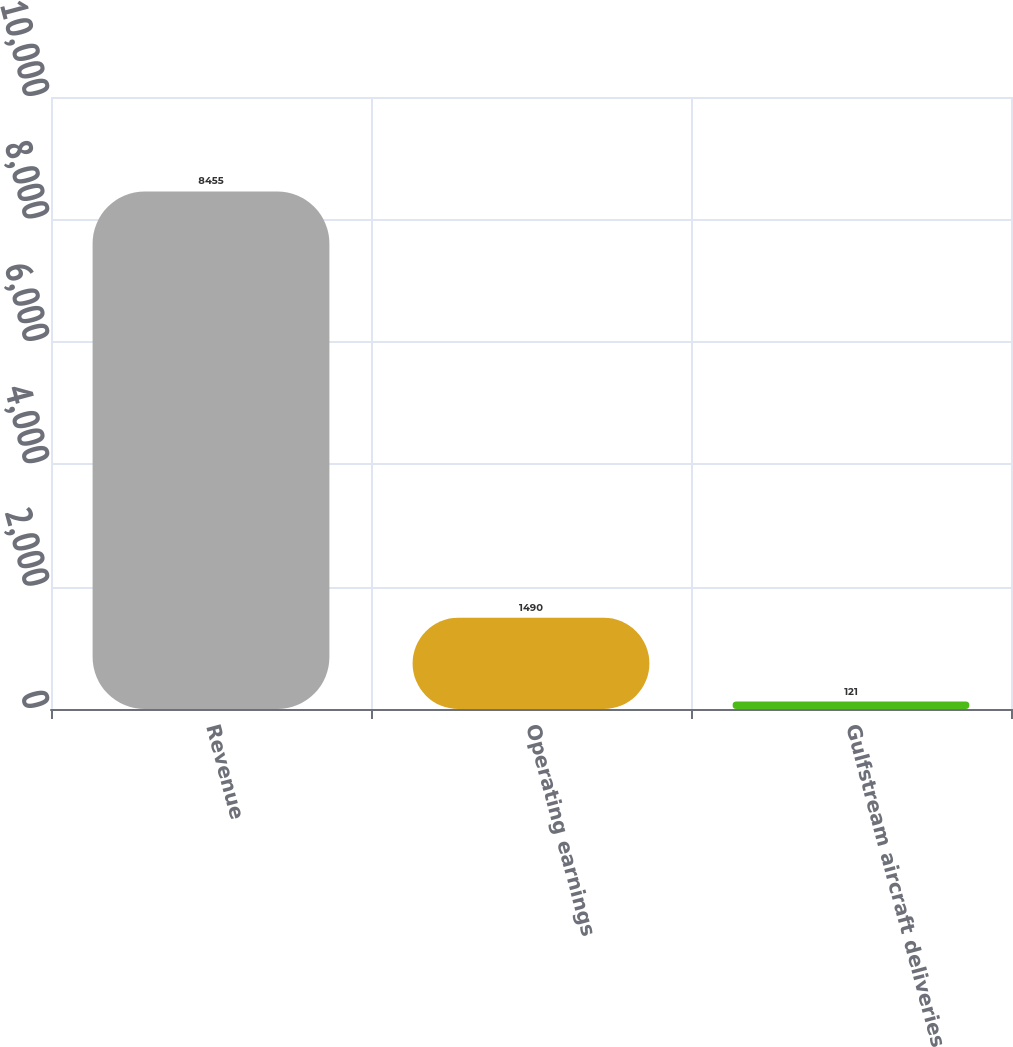<chart> <loc_0><loc_0><loc_500><loc_500><bar_chart><fcel>Revenue<fcel>Operating earnings<fcel>Gulfstream aircraft deliveries<nl><fcel>8455<fcel>1490<fcel>121<nl></chart> 